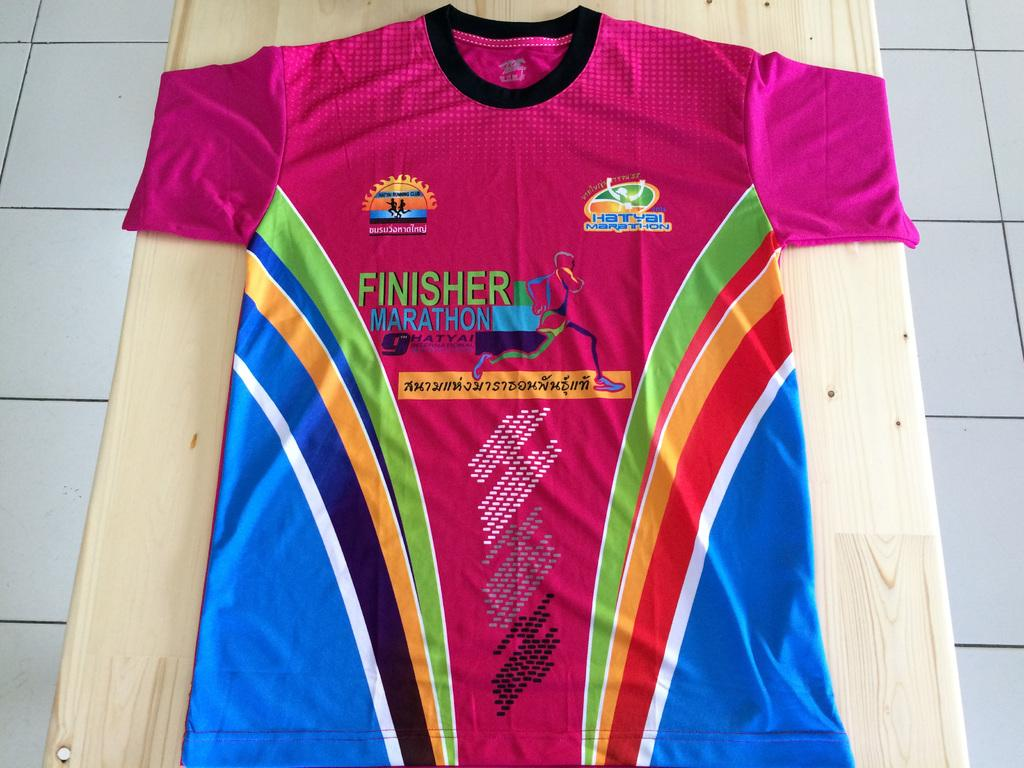<image>
Share a concise interpretation of the image provided. A marathon finisher's t-shirt lies on a wooden surface. 